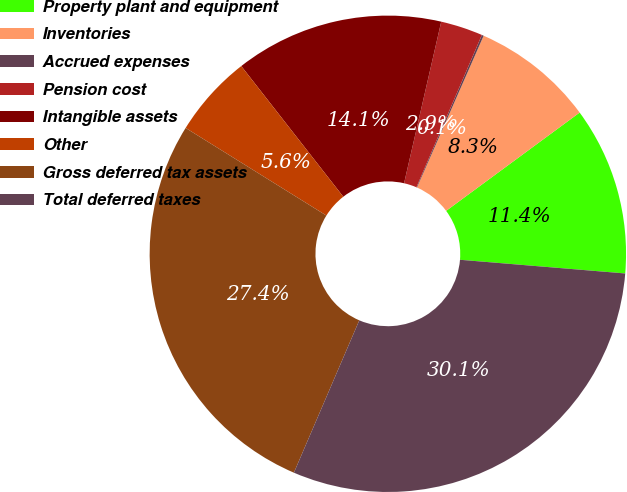Convert chart to OTSL. <chart><loc_0><loc_0><loc_500><loc_500><pie_chart><fcel>Property plant and equipment<fcel>Inventories<fcel>Accrued expenses<fcel>Pension cost<fcel>Intangible assets<fcel>Other<fcel>Gross deferred tax assets<fcel>Total deferred taxes<nl><fcel>11.42%<fcel>8.31%<fcel>0.13%<fcel>2.86%<fcel>14.15%<fcel>5.59%<fcel>27.41%<fcel>30.14%<nl></chart> 